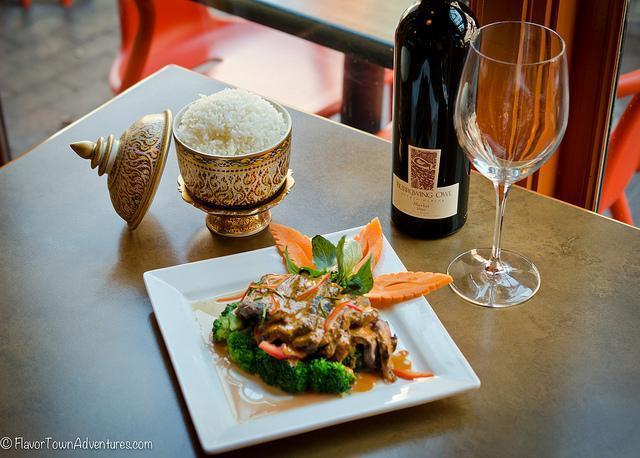How many chairs can you see?
Give a very brief answer. 2. How many bottles are visible?
Give a very brief answer. 1. How many bowls are visible?
Give a very brief answer. 1. 